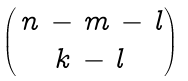<formula> <loc_0><loc_0><loc_500><loc_500>\begin{pmatrix} \, n \, - \, m \, - \, l \\ k \, - \, l \end{pmatrix}</formula> 